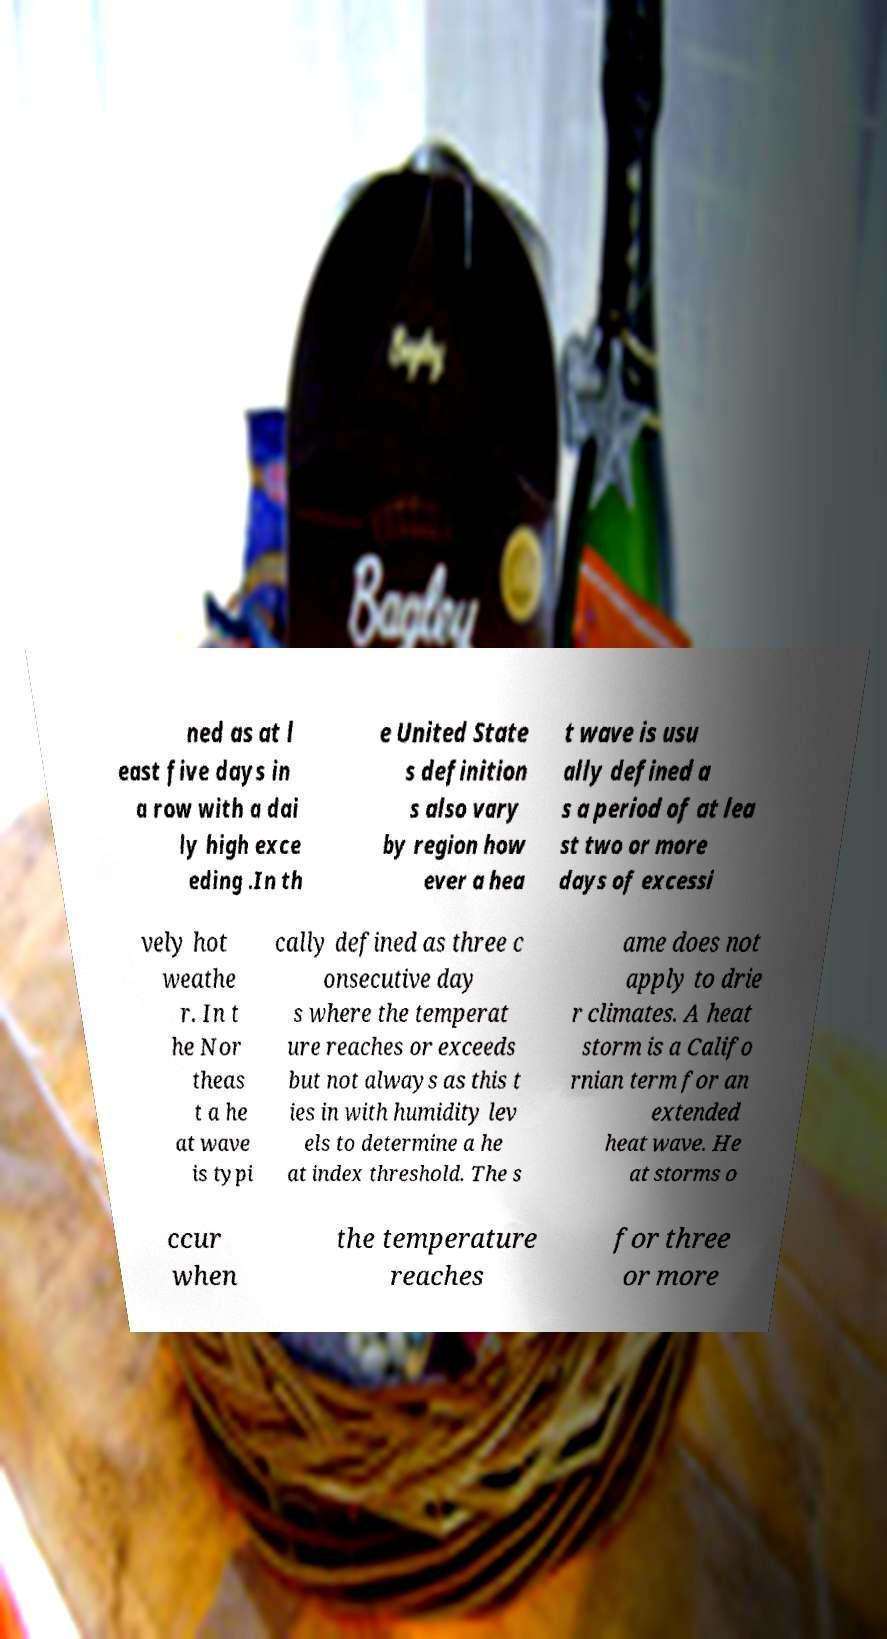For documentation purposes, I need the text within this image transcribed. Could you provide that? ned as at l east five days in a row with a dai ly high exce eding .In th e United State s definition s also vary by region how ever a hea t wave is usu ally defined a s a period of at lea st two or more days of excessi vely hot weathe r. In t he Nor theas t a he at wave is typi cally defined as three c onsecutive day s where the temperat ure reaches or exceeds but not always as this t ies in with humidity lev els to determine a he at index threshold. The s ame does not apply to drie r climates. A heat storm is a Califo rnian term for an extended heat wave. He at storms o ccur when the temperature reaches for three or more 